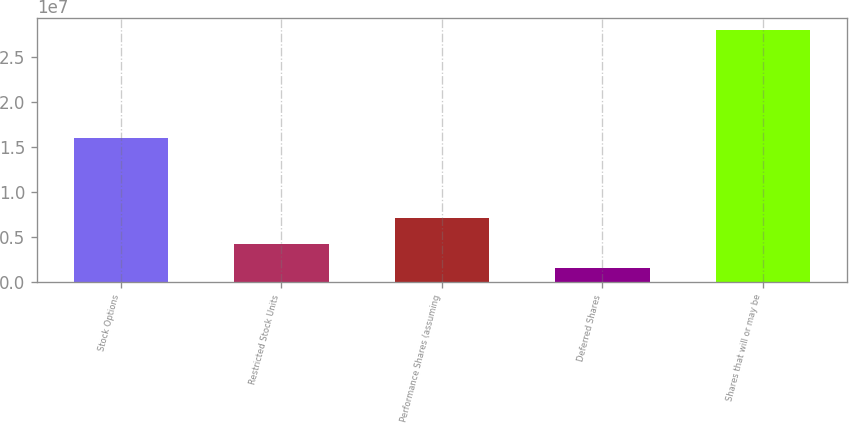Convert chart to OTSL. <chart><loc_0><loc_0><loc_500><loc_500><bar_chart><fcel>Stock Options<fcel>Restricted Stock Units<fcel>Performance Shares (assuming<fcel>Deferred Shares<fcel>Shares that will or may be<nl><fcel>1.60098e+07<fcel>4.2123e+06<fcel>7.05908e+06<fcel>1.57497e+06<fcel>2.79482e+07<nl></chart> 